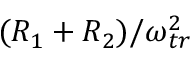<formula> <loc_0><loc_0><loc_500><loc_500>( R _ { 1 } + R _ { 2 } ) / \omega _ { t r } ^ { 2 }</formula> 